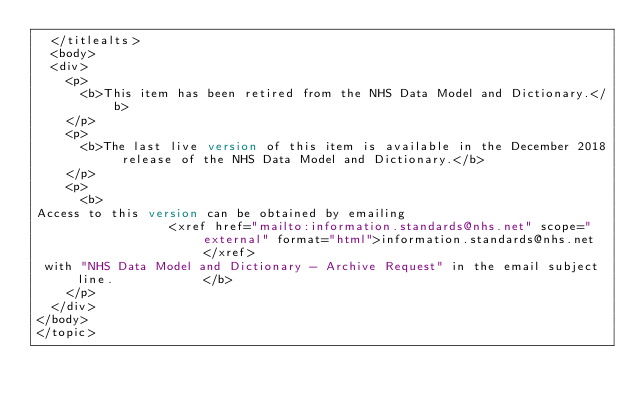<code> <loc_0><loc_0><loc_500><loc_500><_XML_>  </titlealts>
  <body>
  <div>
    <p>
      <b>This item has been retired from the NHS Data Model and Dictionary.</b>
    </p>
    <p>
      <b>The last live version of this item is available in the December 2018 release of the NHS Data Model and Dictionary.</b>
    </p>
    <p>
      <b>
Access to this version can be obtained by emailing 
                  <xref href="mailto:information.standards@nhs.net" scope="external" format="html">information.standards@nhs.net</xref>
 with "NHS Data Model and Dictionary - Archive Request" in the email subject line.            </b>
    </p>
  </div>
</body>
</topic></code> 